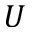Convert formula to latex. <formula><loc_0><loc_0><loc_500><loc_500>U</formula> 